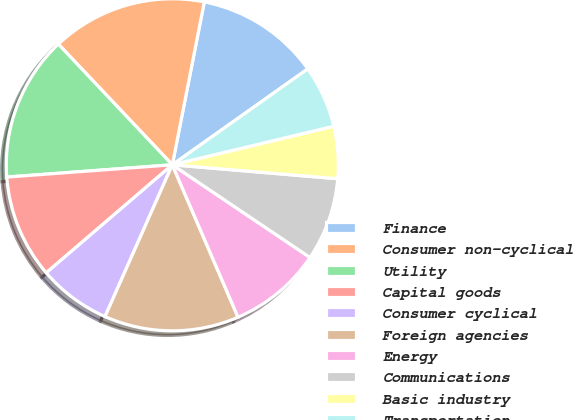Convert chart to OTSL. <chart><loc_0><loc_0><loc_500><loc_500><pie_chart><fcel>Finance<fcel>Consumer non-cyclical<fcel>Utility<fcel>Capital goods<fcel>Consumer cyclical<fcel>Foreign agencies<fcel>Energy<fcel>Communications<fcel>Basic industry<fcel>Transportation<nl><fcel>12.11%<fcel>15.13%<fcel>14.13%<fcel>10.1%<fcel>7.08%<fcel>13.12%<fcel>9.09%<fcel>8.09%<fcel>5.07%<fcel>6.07%<nl></chart> 